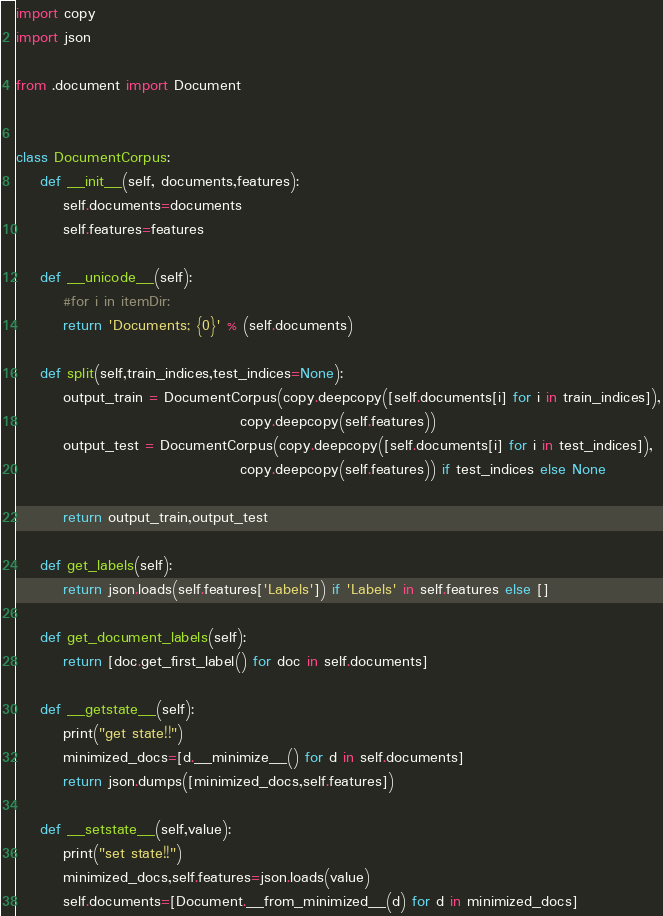<code> <loc_0><loc_0><loc_500><loc_500><_Python_>import copy
import json

from .document import Document


class DocumentCorpus:
    def __init__(self, documents,features):
        self.documents=documents
        self.features=features

    def __unicode__(self):
        #for i in itemDir:
        return 'Documents; {0}' % (self.documents)

    def split(self,train_indices,test_indices=None):
        output_train = DocumentCorpus(copy.deepcopy([self.documents[i] for i in train_indices]),
                                      copy.deepcopy(self.features))
        output_test = DocumentCorpus(copy.deepcopy([self.documents[i] for i in test_indices]),
                                      copy.deepcopy(self.features)) if test_indices else None

        return output_train,output_test

    def get_labels(self):
        return json.loads(self.features['Labels']) if 'Labels' in self.features else []

    def get_document_labels(self):
        return [doc.get_first_label() for doc in self.documents]

    def __getstate__(self):
        print("get state!!")
        minimized_docs=[d.__minimize__() for d in self.documents]
        return json.dumps([minimized_docs,self.features])

    def __setstate__(self,value):
        print("set state!!")
        minimized_docs,self.features=json.loads(value)
        self.documents=[Document.__from_minimized__(d) for d in minimized_docs]


</code> 